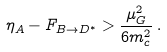Convert formula to latex. <formula><loc_0><loc_0><loc_500><loc_500>\eta _ { A } - F _ { B \rightarrow D ^ { * } } > \frac { \mu _ { G } ^ { 2 } } { 6 m _ { c } ^ { 2 } } \, .</formula> 